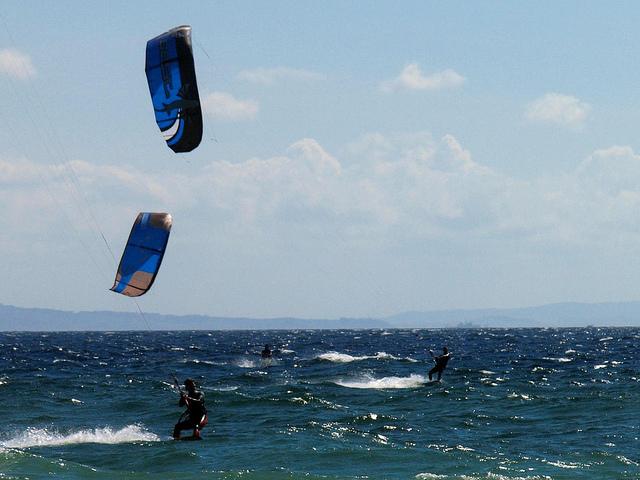Are these people pretty experienced at using this?
Be succinct. Yes. How many people are in the water?
Give a very brief answer. 3. What are the people holding?
Give a very brief answer. Kites. 